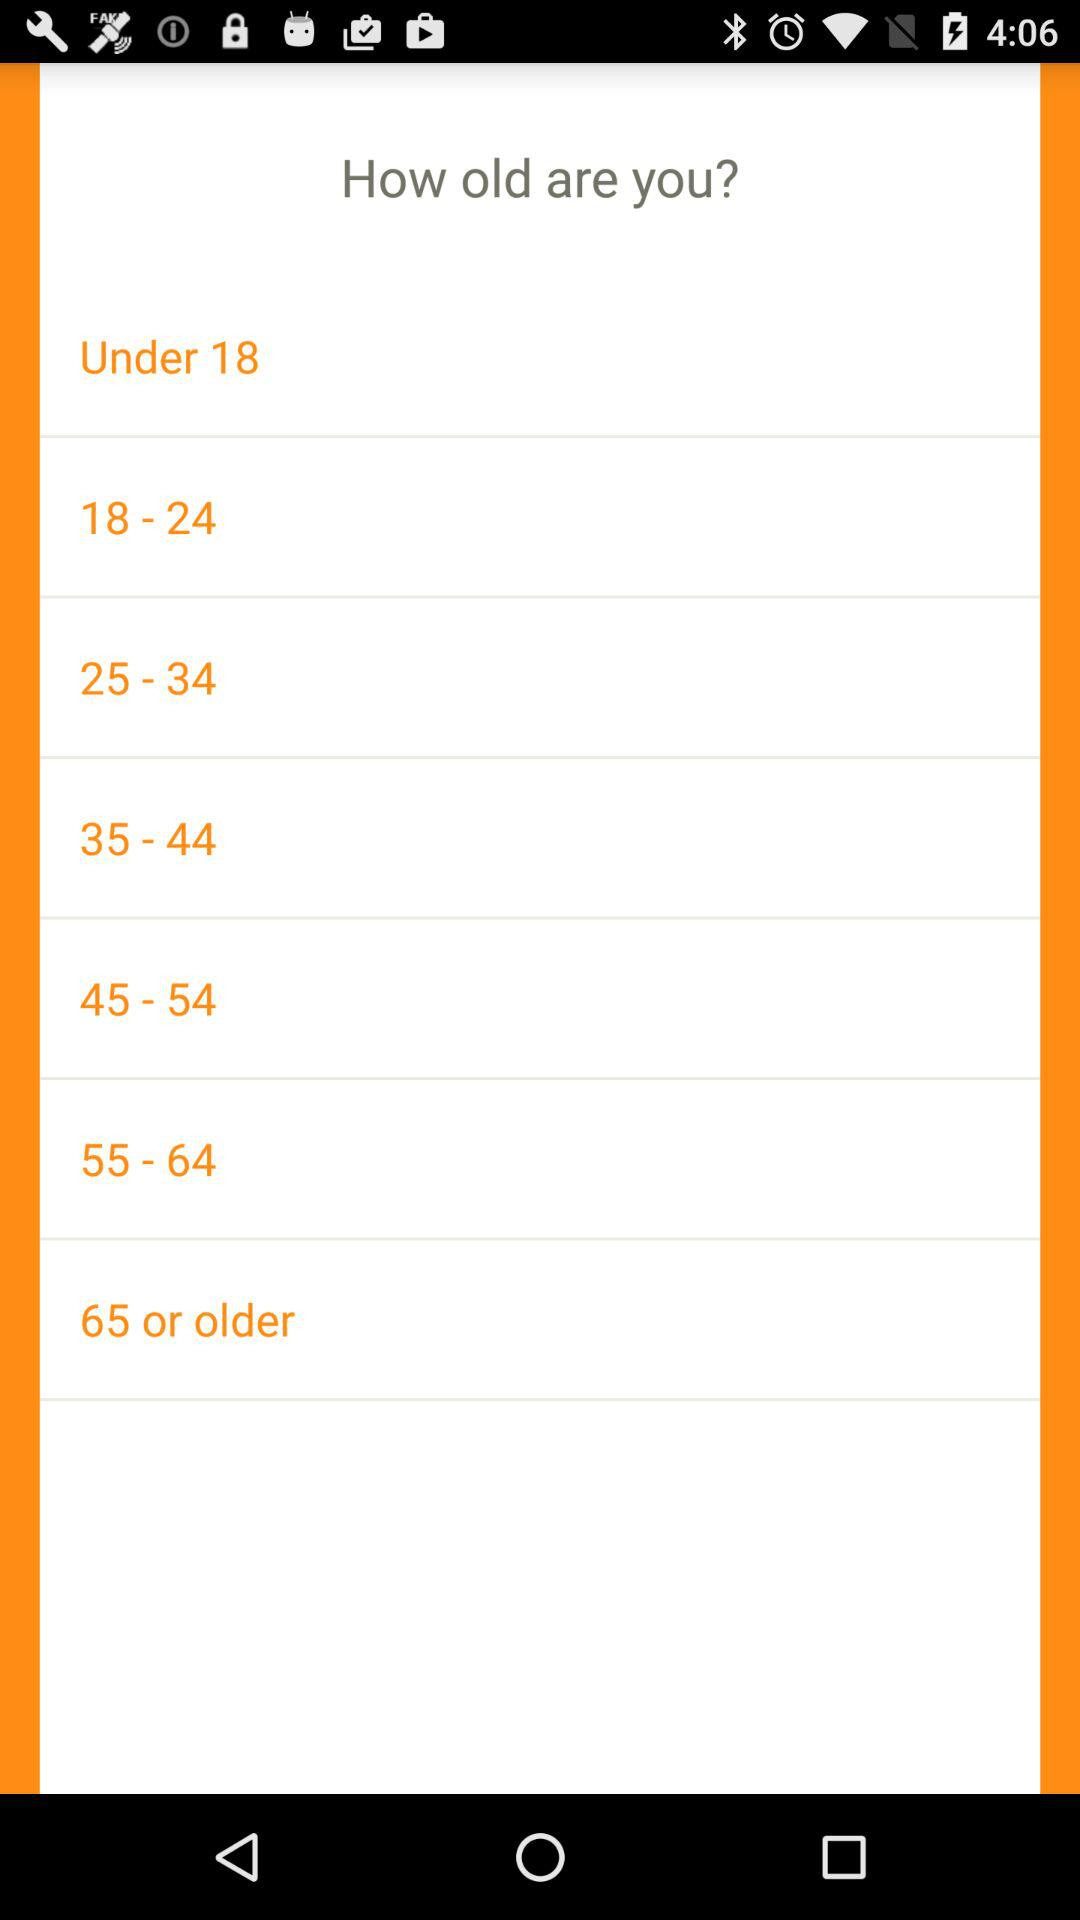How many age groups are there between 18 and 65?
Answer the question using a single word or phrase. 5 